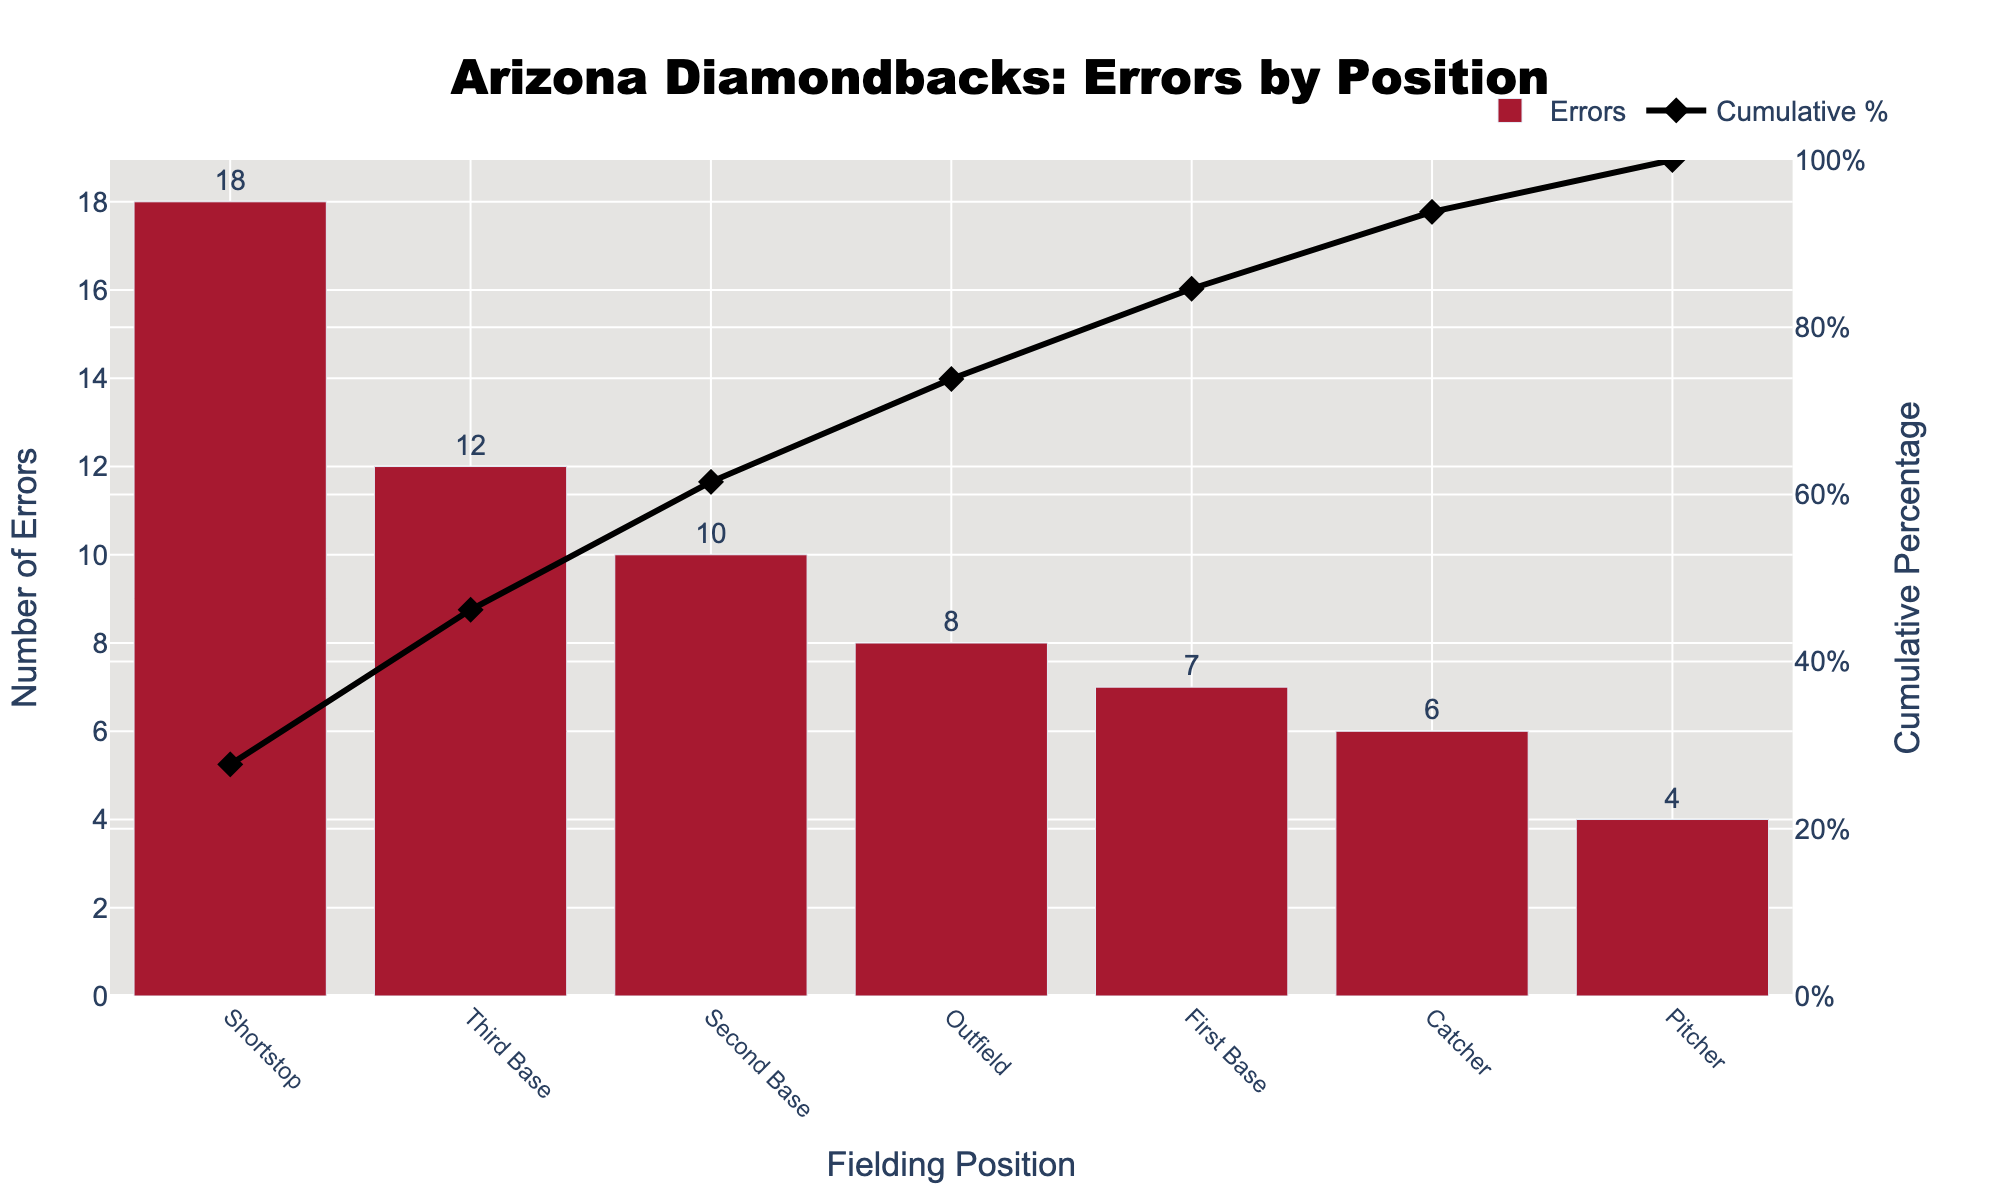Which fielding position committed the most errors? Look at the bar chart and find the position with the tallest bar. The Shortstop position committed the most errors.
Answer: Shortstop Which fielding position committed the least errors? Check the bar chart for the shortest bar. The Pitcher position committed the least errors.
Answer: Pitcher What is the cumulative percentage of errors after Shortstop and Third Base? Add the cumulative percentages of Shortstop (27.7%) and Third Base (18.5%).
Answer: 46.2% What percentage of errors is attributable to Second Base alone? From the table data or the figure, locate the bar for Second Base and refer to the percentage listed. Second Base alone has 10 errors.
Answer: 10 errors How many total errors were committed by combining the errors of Outfield and First Base? Add the errors for Outfield (8) and First Base (7).
Answer: 15 Which position has a cumulative percentage closest to 50%? Check the cumulative percentages, and Third Base is closest to 50%.
Answer: Third Base How many more errors did the Shortstop commit than the Catcher? Subtract the errors committed by the Catcher (6) from the errors committed by the Shortstop (18).
Answer: 12 What is the cumulative percentage of errors after including the errors committed by Second Base? Add the cumulative percentages of positions up to Second Base: 27.7% (Shortstop) + 18.5% (Third Base) + 15.4% (Second Base).
Answer: 61.5% What is the total number of errors committed by all positions combined? Add the errors of all positions: 18 + 12 + 10 + 8 + 7 + 6 + 4.
Answer: 65 How does the cumulative percentage change as we move from Outfield to First Base? The cumulative percentage goes from 73.8% after Outfield to 84.6% after including First Base. The change is 84.6% - 73.8%.
Answer: 10.8% 